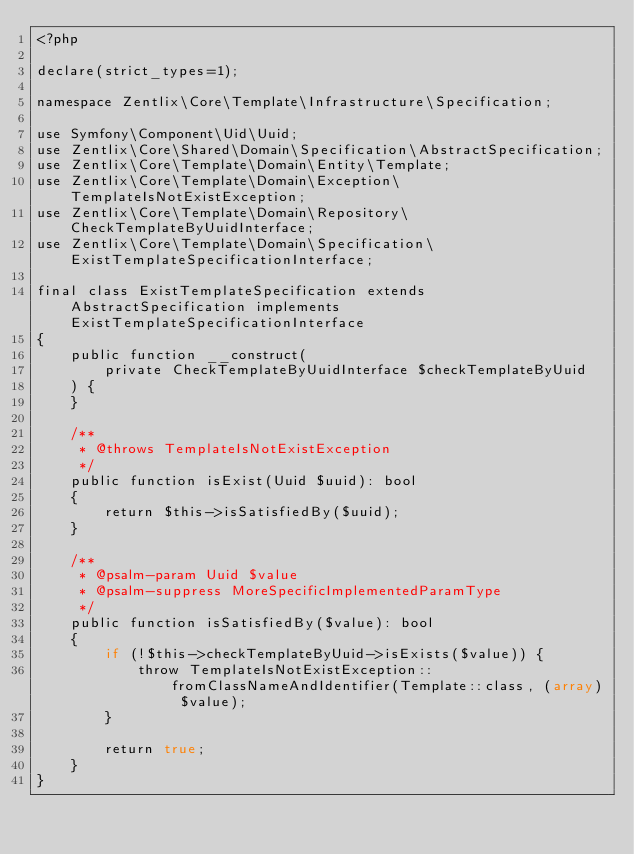<code> <loc_0><loc_0><loc_500><loc_500><_PHP_><?php

declare(strict_types=1);

namespace Zentlix\Core\Template\Infrastructure\Specification;

use Symfony\Component\Uid\Uuid;
use Zentlix\Core\Shared\Domain\Specification\AbstractSpecification;
use Zentlix\Core\Template\Domain\Entity\Template;
use Zentlix\Core\Template\Domain\Exception\TemplateIsNotExistException;
use Zentlix\Core\Template\Domain\Repository\CheckTemplateByUuidInterface;
use Zentlix\Core\Template\Domain\Specification\ExistTemplateSpecificationInterface;

final class ExistTemplateSpecification extends AbstractSpecification implements ExistTemplateSpecificationInterface
{
    public function __construct(
        private CheckTemplateByUuidInterface $checkTemplateByUuid
    ) {
    }

    /**
     * @throws TemplateIsNotExistException
     */
    public function isExist(Uuid $uuid): bool
    {
        return $this->isSatisfiedBy($uuid);
    }

    /**
     * @psalm-param Uuid $value
     * @psalm-suppress MoreSpecificImplementedParamType
     */
    public function isSatisfiedBy($value): bool
    {
        if (!$this->checkTemplateByUuid->isExists($value)) {
            throw TemplateIsNotExistException::fromClassNameAndIdentifier(Template::class, (array) $value);
        }

        return true;
    }
}
</code> 